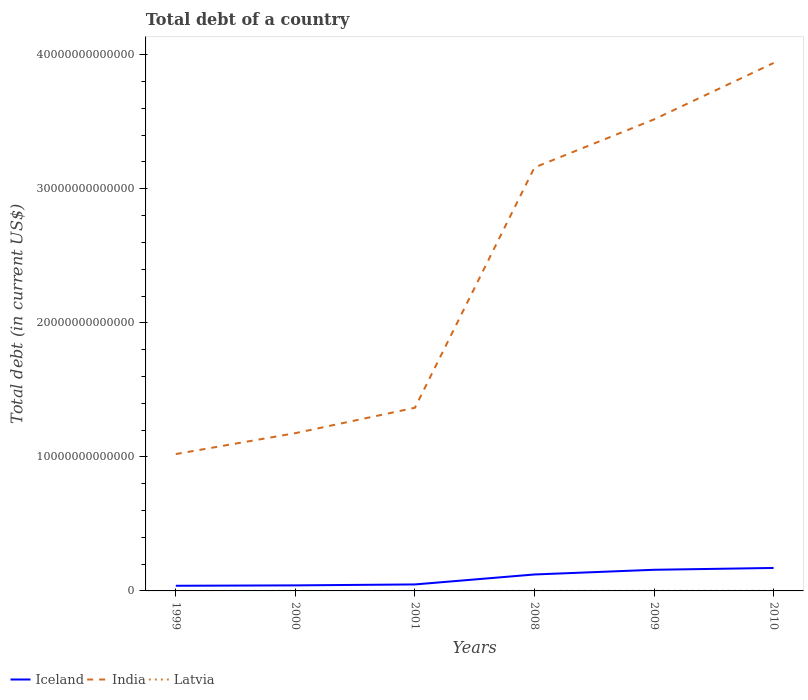How many different coloured lines are there?
Your answer should be compact. 3. Does the line corresponding to Latvia intersect with the line corresponding to India?
Give a very brief answer. No. Is the number of lines equal to the number of legend labels?
Provide a succinct answer. Yes. Across all years, what is the maximum debt in India?
Offer a terse response. 1.02e+13. In which year was the debt in Iceland maximum?
Your answer should be compact. 1999. What is the total debt in India in the graph?
Your response must be concise. -1.79e+13. What is the difference between the highest and the second highest debt in Latvia?
Your answer should be very brief. 5.84e+09. What is the difference between two consecutive major ticks on the Y-axis?
Provide a succinct answer. 1.00e+13. Are the values on the major ticks of Y-axis written in scientific E-notation?
Keep it short and to the point. No. Does the graph contain any zero values?
Offer a terse response. No. Where does the legend appear in the graph?
Ensure brevity in your answer.  Bottom left. How are the legend labels stacked?
Offer a very short reply. Horizontal. What is the title of the graph?
Your answer should be very brief. Total debt of a country. Does "Serbia" appear as one of the legend labels in the graph?
Your answer should be very brief. No. What is the label or title of the X-axis?
Ensure brevity in your answer.  Years. What is the label or title of the Y-axis?
Offer a very short reply. Total debt (in current US$). What is the Total debt (in current US$) of Iceland in 1999?
Your answer should be very brief. 3.84e+11. What is the Total debt (in current US$) of India in 1999?
Give a very brief answer. 1.02e+13. What is the Total debt (in current US$) in Latvia in 1999?
Keep it short and to the point. 5.11e+08. What is the Total debt (in current US$) of Iceland in 2000?
Give a very brief answer. 4.13e+11. What is the Total debt (in current US$) in India in 2000?
Ensure brevity in your answer.  1.18e+13. What is the Total debt (in current US$) of Latvia in 2000?
Provide a short and direct response. 5.71e+08. What is the Total debt (in current US$) of Iceland in 2001?
Give a very brief answer. 4.84e+11. What is the Total debt (in current US$) in India in 2001?
Offer a very short reply. 1.37e+13. What is the Total debt (in current US$) in Latvia in 2001?
Offer a terse response. 7.13e+08. What is the Total debt (in current US$) in Iceland in 2008?
Make the answer very short. 1.23e+12. What is the Total debt (in current US$) of India in 2008?
Your answer should be very brief. 3.16e+13. What is the Total debt (in current US$) of Latvia in 2008?
Your response must be concise. 3.71e+09. What is the Total debt (in current US$) of Iceland in 2009?
Your answer should be very brief. 1.58e+12. What is the Total debt (in current US$) of India in 2009?
Ensure brevity in your answer.  3.52e+13. What is the Total debt (in current US$) in Latvia in 2009?
Provide a succinct answer. 5.52e+09. What is the Total debt (in current US$) in Iceland in 2010?
Ensure brevity in your answer.  1.71e+12. What is the Total debt (in current US$) of India in 2010?
Your answer should be compact. 3.94e+13. What is the Total debt (in current US$) in Latvia in 2010?
Your answer should be very brief. 6.35e+09. Across all years, what is the maximum Total debt (in current US$) in Iceland?
Keep it short and to the point. 1.71e+12. Across all years, what is the maximum Total debt (in current US$) of India?
Provide a succinct answer. 3.94e+13. Across all years, what is the maximum Total debt (in current US$) in Latvia?
Provide a short and direct response. 6.35e+09. Across all years, what is the minimum Total debt (in current US$) of Iceland?
Provide a short and direct response. 3.84e+11. Across all years, what is the minimum Total debt (in current US$) of India?
Your response must be concise. 1.02e+13. Across all years, what is the minimum Total debt (in current US$) of Latvia?
Ensure brevity in your answer.  5.11e+08. What is the total Total debt (in current US$) in Iceland in the graph?
Ensure brevity in your answer.  5.80e+12. What is the total Total debt (in current US$) of India in the graph?
Ensure brevity in your answer.  1.42e+14. What is the total Total debt (in current US$) in Latvia in the graph?
Provide a succinct answer. 1.74e+1. What is the difference between the Total debt (in current US$) of Iceland in 1999 and that in 2000?
Your answer should be very brief. -2.90e+1. What is the difference between the Total debt (in current US$) in India in 1999 and that in 2000?
Make the answer very short. -1.56e+12. What is the difference between the Total debt (in current US$) of Latvia in 1999 and that in 2000?
Make the answer very short. -6.02e+07. What is the difference between the Total debt (in current US$) of Iceland in 1999 and that in 2001?
Keep it short and to the point. -9.93e+1. What is the difference between the Total debt (in current US$) of India in 1999 and that in 2001?
Your response must be concise. -3.45e+12. What is the difference between the Total debt (in current US$) of Latvia in 1999 and that in 2001?
Offer a terse response. -2.02e+08. What is the difference between the Total debt (in current US$) of Iceland in 1999 and that in 2008?
Keep it short and to the point. -8.43e+11. What is the difference between the Total debt (in current US$) in India in 1999 and that in 2008?
Offer a very short reply. -2.14e+13. What is the difference between the Total debt (in current US$) of Latvia in 1999 and that in 2008?
Keep it short and to the point. -3.20e+09. What is the difference between the Total debt (in current US$) of Iceland in 1999 and that in 2009?
Keep it short and to the point. -1.19e+12. What is the difference between the Total debt (in current US$) in India in 1999 and that in 2009?
Your answer should be compact. -2.50e+13. What is the difference between the Total debt (in current US$) of Latvia in 1999 and that in 2009?
Provide a succinct answer. -5.01e+09. What is the difference between the Total debt (in current US$) in Iceland in 1999 and that in 2010?
Ensure brevity in your answer.  -1.33e+12. What is the difference between the Total debt (in current US$) in India in 1999 and that in 2010?
Your answer should be very brief. -2.92e+13. What is the difference between the Total debt (in current US$) in Latvia in 1999 and that in 2010?
Your response must be concise. -5.84e+09. What is the difference between the Total debt (in current US$) of Iceland in 2000 and that in 2001?
Your answer should be compact. -7.03e+1. What is the difference between the Total debt (in current US$) of India in 2000 and that in 2001?
Make the answer very short. -1.89e+12. What is the difference between the Total debt (in current US$) of Latvia in 2000 and that in 2001?
Make the answer very short. -1.42e+08. What is the difference between the Total debt (in current US$) of Iceland in 2000 and that in 2008?
Make the answer very short. -8.14e+11. What is the difference between the Total debt (in current US$) of India in 2000 and that in 2008?
Offer a very short reply. -1.98e+13. What is the difference between the Total debt (in current US$) of Latvia in 2000 and that in 2008?
Provide a short and direct response. -3.14e+09. What is the difference between the Total debt (in current US$) in Iceland in 2000 and that in 2009?
Provide a succinct answer. -1.16e+12. What is the difference between the Total debt (in current US$) of India in 2000 and that in 2009?
Provide a short and direct response. -2.34e+13. What is the difference between the Total debt (in current US$) of Latvia in 2000 and that in 2009?
Provide a short and direct response. -4.95e+09. What is the difference between the Total debt (in current US$) in Iceland in 2000 and that in 2010?
Provide a succinct answer. -1.30e+12. What is the difference between the Total debt (in current US$) of India in 2000 and that in 2010?
Offer a very short reply. -2.76e+13. What is the difference between the Total debt (in current US$) of Latvia in 2000 and that in 2010?
Offer a terse response. -5.78e+09. What is the difference between the Total debt (in current US$) of Iceland in 2001 and that in 2008?
Keep it short and to the point. -7.44e+11. What is the difference between the Total debt (in current US$) in India in 2001 and that in 2008?
Offer a very short reply. -1.79e+13. What is the difference between the Total debt (in current US$) in Latvia in 2001 and that in 2008?
Make the answer very short. -2.99e+09. What is the difference between the Total debt (in current US$) of Iceland in 2001 and that in 2009?
Provide a short and direct response. -1.09e+12. What is the difference between the Total debt (in current US$) in India in 2001 and that in 2009?
Your response must be concise. -2.15e+13. What is the difference between the Total debt (in current US$) in Latvia in 2001 and that in 2009?
Your answer should be very brief. -4.80e+09. What is the difference between the Total debt (in current US$) in Iceland in 2001 and that in 2010?
Offer a terse response. -1.23e+12. What is the difference between the Total debt (in current US$) in India in 2001 and that in 2010?
Ensure brevity in your answer.  -2.57e+13. What is the difference between the Total debt (in current US$) of Latvia in 2001 and that in 2010?
Your answer should be very brief. -5.64e+09. What is the difference between the Total debt (in current US$) in Iceland in 2008 and that in 2009?
Your answer should be very brief. -3.50e+11. What is the difference between the Total debt (in current US$) of India in 2008 and that in 2009?
Offer a terse response. -3.59e+12. What is the difference between the Total debt (in current US$) of Latvia in 2008 and that in 2009?
Your answer should be very brief. -1.81e+09. What is the difference between the Total debt (in current US$) in Iceland in 2008 and that in 2010?
Provide a succinct answer. -4.86e+11. What is the difference between the Total debt (in current US$) in India in 2008 and that in 2010?
Provide a short and direct response. -7.80e+12. What is the difference between the Total debt (in current US$) of Latvia in 2008 and that in 2010?
Your answer should be very brief. -2.65e+09. What is the difference between the Total debt (in current US$) in Iceland in 2009 and that in 2010?
Your answer should be very brief. -1.36e+11. What is the difference between the Total debt (in current US$) of India in 2009 and that in 2010?
Offer a very short reply. -4.21e+12. What is the difference between the Total debt (in current US$) in Latvia in 2009 and that in 2010?
Your response must be concise. -8.37e+08. What is the difference between the Total debt (in current US$) in Iceland in 1999 and the Total debt (in current US$) in India in 2000?
Provide a succinct answer. -1.14e+13. What is the difference between the Total debt (in current US$) of Iceland in 1999 and the Total debt (in current US$) of Latvia in 2000?
Provide a succinct answer. 3.84e+11. What is the difference between the Total debt (in current US$) in India in 1999 and the Total debt (in current US$) in Latvia in 2000?
Offer a very short reply. 1.02e+13. What is the difference between the Total debt (in current US$) of Iceland in 1999 and the Total debt (in current US$) of India in 2001?
Offer a terse response. -1.33e+13. What is the difference between the Total debt (in current US$) in Iceland in 1999 and the Total debt (in current US$) in Latvia in 2001?
Make the answer very short. 3.84e+11. What is the difference between the Total debt (in current US$) of India in 1999 and the Total debt (in current US$) of Latvia in 2001?
Offer a terse response. 1.02e+13. What is the difference between the Total debt (in current US$) of Iceland in 1999 and the Total debt (in current US$) of India in 2008?
Give a very brief answer. -3.12e+13. What is the difference between the Total debt (in current US$) in Iceland in 1999 and the Total debt (in current US$) in Latvia in 2008?
Keep it short and to the point. 3.81e+11. What is the difference between the Total debt (in current US$) of India in 1999 and the Total debt (in current US$) of Latvia in 2008?
Offer a very short reply. 1.02e+13. What is the difference between the Total debt (in current US$) in Iceland in 1999 and the Total debt (in current US$) in India in 2009?
Your answer should be compact. -3.48e+13. What is the difference between the Total debt (in current US$) of Iceland in 1999 and the Total debt (in current US$) of Latvia in 2009?
Offer a very short reply. 3.79e+11. What is the difference between the Total debt (in current US$) of India in 1999 and the Total debt (in current US$) of Latvia in 2009?
Ensure brevity in your answer.  1.02e+13. What is the difference between the Total debt (in current US$) of Iceland in 1999 and the Total debt (in current US$) of India in 2010?
Make the answer very short. -3.90e+13. What is the difference between the Total debt (in current US$) of Iceland in 1999 and the Total debt (in current US$) of Latvia in 2010?
Give a very brief answer. 3.78e+11. What is the difference between the Total debt (in current US$) in India in 1999 and the Total debt (in current US$) in Latvia in 2010?
Give a very brief answer. 1.02e+13. What is the difference between the Total debt (in current US$) of Iceland in 2000 and the Total debt (in current US$) of India in 2001?
Make the answer very short. -1.33e+13. What is the difference between the Total debt (in current US$) of Iceland in 2000 and the Total debt (in current US$) of Latvia in 2001?
Provide a succinct answer. 4.13e+11. What is the difference between the Total debt (in current US$) in India in 2000 and the Total debt (in current US$) in Latvia in 2001?
Offer a terse response. 1.18e+13. What is the difference between the Total debt (in current US$) of Iceland in 2000 and the Total debt (in current US$) of India in 2008?
Provide a short and direct response. -3.12e+13. What is the difference between the Total debt (in current US$) in Iceland in 2000 and the Total debt (in current US$) in Latvia in 2008?
Make the answer very short. 4.10e+11. What is the difference between the Total debt (in current US$) of India in 2000 and the Total debt (in current US$) of Latvia in 2008?
Ensure brevity in your answer.  1.18e+13. What is the difference between the Total debt (in current US$) of Iceland in 2000 and the Total debt (in current US$) of India in 2009?
Offer a terse response. -3.48e+13. What is the difference between the Total debt (in current US$) in Iceland in 2000 and the Total debt (in current US$) in Latvia in 2009?
Give a very brief answer. 4.08e+11. What is the difference between the Total debt (in current US$) of India in 2000 and the Total debt (in current US$) of Latvia in 2009?
Give a very brief answer. 1.18e+13. What is the difference between the Total debt (in current US$) of Iceland in 2000 and the Total debt (in current US$) of India in 2010?
Your answer should be compact. -3.90e+13. What is the difference between the Total debt (in current US$) in Iceland in 2000 and the Total debt (in current US$) in Latvia in 2010?
Make the answer very short. 4.07e+11. What is the difference between the Total debt (in current US$) of India in 2000 and the Total debt (in current US$) of Latvia in 2010?
Your response must be concise. 1.18e+13. What is the difference between the Total debt (in current US$) of Iceland in 2001 and the Total debt (in current US$) of India in 2008?
Provide a succinct answer. -3.11e+13. What is the difference between the Total debt (in current US$) in Iceland in 2001 and the Total debt (in current US$) in Latvia in 2008?
Provide a succinct answer. 4.80e+11. What is the difference between the Total debt (in current US$) of India in 2001 and the Total debt (in current US$) of Latvia in 2008?
Offer a terse response. 1.37e+13. What is the difference between the Total debt (in current US$) of Iceland in 2001 and the Total debt (in current US$) of India in 2009?
Your answer should be very brief. -3.47e+13. What is the difference between the Total debt (in current US$) in Iceland in 2001 and the Total debt (in current US$) in Latvia in 2009?
Keep it short and to the point. 4.78e+11. What is the difference between the Total debt (in current US$) in India in 2001 and the Total debt (in current US$) in Latvia in 2009?
Give a very brief answer. 1.37e+13. What is the difference between the Total debt (in current US$) in Iceland in 2001 and the Total debt (in current US$) in India in 2010?
Keep it short and to the point. -3.89e+13. What is the difference between the Total debt (in current US$) of Iceland in 2001 and the Total debt (in current US$) of Latvia in 2010?
Provide a succinct answer. 4.77e+11. What is the difference between the Total debt (in current US$) of India in 2001 and the Total debt (in current US$) of Latvia in 2010?
Offer a terse response. 1.37e+13. What is the difference between the Total debt (in current US$) in Iceland in 2008 and the Total debt (in current US$) in India in 2009?
Provide a succinct answer. -3.40e+13. What is the difference between the Total debt (in current US$) in Iceland in 2008 and the Total debt (in current US$) in Latvia in 2009?
Provide a succinct answer. 1.22e+12. What is the difference between the Total debt (in current US$) in India in 2008 and the Total debt (in current US$) in Latvia in 2009?
Your answer should be compact. 3.16e+13. What is the difference between the Total debt (in current US$) of Iceland in 2008 and the Total debt (in current US$) of India in 2010?
Provide a short and direct response. -3.82e+13. What is the difference between the Total debt (in current US$) in Iceland in 2008 and the Total debt (in current US$) in Latvia in 2010?
Provide a succinct answer. 1.22e+12. What is the difference between the Total debt (in current US$) in India in 2008 and the Total debt (in current US$) in Latvia in 2010?
Provide a succinct answer. 3.16e+13. What is the difference between the Total debt (in current US$) in Iceland in 2009 and the Total debt (in current US$) in India in 2010?
Offer a very short reply. -3.78e+13. What is the difference between the Total debt (in current US$) of Iceland in 2009 and the Total debt (in current US$) of Latvia in 2010?
Offer a very short reply. 1.57e+12. What is the difference between the Total debt (in current US$) of India in 2009 and the Total debt (in current US$) of Latvia in 2010?
Keep it short and to the point. 3.52e+13. What is the average Total debt (in current US$) of Iceland per year?
Your answer should be compact. 9.67e+11. What is the average Total debt (in current US$) of India per year?
Provide a succinct answer. 2.36e+13. What is the average Total debt (in current US$) in Latvia per year?
Your answer should be very brief. 2.89e+09. In the year 1999, what is the difference between the Total debt (in current US$) in Iceland and Total debt (in current US$) in India?
Your response must be concise. -9.83e+12. In the year 1999, what is the difference between the Total debt (in current US$) of Iceland and Total debt (in current US$) of Latvia?
Your response must be concise. 3.84e+11. In the year 1999, what is the difference between the Total debt (in current US$) of India and Total debt (in current US$) of Latvia?
Ensure brevity in your answer.  1.02e+13. In the year 2000, what is the difference between the Total debt (in current US$) of Iceland and Total debt (in current US$) of India?
Give a very brief answer. -1.14e+13. In the year 2000, what is the difference between the Total debt (in current US$) in Iceland and Total debt (in current US$) in Latvia?
Your response must be concise. 4.13e+11. In the year 2000, what is the difference between the Total debt (in current US$) of India and Total debt (in current US$) of Latvia?
Provide a short and direct response. 1.18e+13. In the year 2001, what is the difference between the Total debt (in current US$) in Iceland and Total debt (in current US$) in India?
Provide a short and direct response. -1.32e+13. In the year 2001, what is the difference between the Total debt (in current US$) in Iceland and Total debt (in current US$) in Latvia?
Make the answer very short. 4.83e+11. In the year 2001, what is the difference between the Total debt (in current US$) of India and Total debt (in current US$) of Latvia?
Your response must be concise. 1.37e+13. In the year 2008, what is the difference between the Total debt (in current US$) of Iceland and Total debt (in current US$) of India?
Provide a short and direct response. -3.04e+13. In the year 2008, what is the difference between the Total debt (in current US$) in Iceland and Total debt (in current US$) in Latvia?
Provide a short and direct response. 1.22e+12. In the year 2008, what is the difference between the Total debt (in current US$) of India and Total debt (in current US$) of Latvia?
Give a very brief answer. 3.16e+13. In the year 2009, what is the difference between the Total debt (in current US$) of Iceland and Total debt (in current US$) of India?
Provide a short and direct response. -3.36e+13. In the year 2009, what is the difference between the Total debt (in current US$) in Iceland and Total debt (in current US$) in Latvia?
Your answer should be very brief. 1.57e+12. In the year 2009, what is the difference between the Total debt (in current US$) of India and Total debt (in current US$) of Latvia?
Your response must be concise. 3.52e+13. In the year 2010, what is the difference between the Total debt (in current US$) in Iceland and Total debt (in current US$) in India?
Provide a succinct answer. -3.77e+13. In the year 2010, what is the difference between the Total debt (in current US$) in Iceland and Total debt (in current US$) in Latvia?
Provide a short and direct response. 1.71e+12. In the year 2010, what is the difference between the Total debt (in current US$) in India and Total debt (in current US$) in Latvia?
Ensure brevity in your answer.  3.94e+13. What is the ratio of the Total debt (in current US$) in Iceland in 1999 to that in 2000?
Offer a very short reply. 0.93. What is the ratio of the Total debt (in current US$) in India in 1999 to that in 2000?
Ensure brevity in your answer.  0.87. What is the ratio of the Total debt (in current US$) of Latvia in 1999 to that in 2000?
Provide a short and direct response. 0.89. What is the ratio of the Total debt (in current US$) in Iceland in 1999 to that in 2001?
Give a very brief answer. 0.79. What is the ratio of the Total debt (in current US$) in India in 1999 to that in 2001?
Give a very brief answer. 0.75. What is the ratio of the Total debt (in current US$) of Latvia in 1999 to that in 2001?
Ensure brevity in your answer.  0.72. What is the ratio of the Total debt (in current US$) in Iceland in 1999 to that in 2008?
Offer a very short reply. 0.31. What is the ratio of the Total debt (in current US$) in India in 1999 to that in 2008?
Your answer should be very brief. 0.32. What is the ratio of the Total debt (in current US$) of Latvia in 1999 to that in 2008?
Provide a short and direct response. 0.14. What is the ratio of the Total debt (in current US$) of Iceland in 1999 to that in 2009?
Offer a very short reply. 0.24. What is the ratio of the Total debt (in current US$) in India in 1999 to that in 2009?
Make the answer very short. 0.29. What is the ratio of the Total debt (in current US$) of Latvia in 1999 to that in 2009?
Make the answer very short. 0.09. What is the ratio of the Total debt (in current US$) of Iceland in 1999 to that in 2010?
Your response must be concise. 0.22. What is the ratio of the Total debt (in current US$) of India in 1999 to that in 2010?
Provide a succinct answer. 0.26. What is the ratio of the Total debt (in current US$) in Latvia in 1999 to that in 2010?
Make the answer very short. 0.08. What is the ratio of the Total debt (in current US$) of Iceland in 2000 to that in 2001?
Make the answer very short. 0.85. What is the ratio of the Total debt (in current US$) of India in 2000 to that in 2001?
Ensure brevity in your answer.  0.86. What is the ratio of the Total debt (in current US$) in Latvia in 2000 to that in 2001?
Make the answer very short. 0.8. What is the ratio of the Total debt (in current US$) of Iceland in 2000 to that in 2008?
Make the answer very short. 0.34. What is the ratio of the Total debt (in current US$) of India in 2000 to that in 2008?
Provide a succinct answer. 0.37. What is the ratio of the Total debt (in current US$) in Latvia in 2000 to that in 2008?
Make the answer very short. 0.15. What is the ratio of the Total debt (in current US$) in Iceland in 2000 to that in 2009?
Offer a terse response. 0.26. What is the ratio of the Total debt (in current US$) of India in 2000 to that in 2009?
Give a very brief answer. 0.33. What is the ratio of the Total debt (in current US$) of Latvia in 2000 to that in 2009?
Provide a short and direct response. 0.1. What is the ratio of the Total debt (in current US$) of Iceland in 2000 to that in 2010?
Offer a very short reply. 0.24. What is the ratio of the Total debt (in current US$) of India in 2000 to that in 2010?
Give a very brief answer. 0.3. What is the ratio of the Total debt (in current US$) of Latvia in 2000 to that in 2010?
Keep it short and to the point. 0.09. What is the ratio of the Total debt (in current US$) of Iceland in 2001 to that in 2008?
Provide a short and direct response. 0.39. What is the ratio of the Total debt (in current US$) in India in 2001 to that in 2008?
Keep it short and to the point. 0.43. What is the ratio of the Total debt (in current US$) in Latvia in 2001 to that in 2008?
Your answer should be compact. 0.19. What is the ratio of the Total debt (in current US$) of Iceland in 2001 to that in 2009?
Offer a very short reply. 0.31. What is the ratio of the Total debt (in current US$) of India in 2001 to that in 2009?
Offer a terse response. 0.39. What is the ratio of the Total debt (in current US$) in Latvia in 2001 to that in 2009?
Provide a short and direct response. 0.13. What is the ratio of the Total debt (in current US$) in Iceland in 2001 to that in 2010?
Your answer should be very brief. 0.28. What is the ratio of the Total debt (in current US$) of India in 2001 to that in 2010?
Provide a succinct answer. 0.35. What is the ratio of the Total debt (in current US$) of Latvia in 2001 to that in 2010?
Your response must be concise. 0.11. What is the ratio of the Total debt (in current US$) of Iceland in 2008 to that in 2009?
Offer a terse response. 0.78. What is the ratio of the Total debt (in current US$) in India in 2008 to that in 2009?
Give a very brief answer. 0.9. What is the ratio of the Total debt (in current US$) in Latvia in 2008 to that in 2009?
Give a very brief answer. 0.67. What is the ratio of the Total debt (in current US$) of Iceland in 2008 to that in 2010?
Provide a succinct answer. 0.72. What is the ratio of the Total debt (in current US$) of India in 2008 to that in 2010?
Keep it short and to the point. 0.8. What is the ratio of the Total debt (in current US$) of Latvia in 2008 to that in 2010?
Your response must be concise. 0.58. What is the ratio of the Total debt (in current US$) in Iceland in 2009 to that in 2010?
Your answer should be compact. 0.92. What is the ratio of the Total debt (in current US$) in India in 2009 to that in 2010?
Offer a terse response. 0.89. What is the ratio of the Total debt (in current US$) of Latvia in 2009 to that in 2010?
Offer a very short reply. 0.87. What is the difference between the highest and the second highest Total debt (in current US$) in Iceland?
Ensure brevity in your answer.  1.36e+11. What is the difference between the highest and the second highest Total debt (in current US$) of India?
Offer a very short reply. 4.21e+12. What is the difference between the highest and the second highest Total debt (in current US$) in Latvia?
Your response must be concise. 8.37e+08. What is the difference between the highest and the lowest Total debt (in current US$) in Iceland?
Provide a succinct answer. 1.33e+12. What is the difference between the highest and the lowest Total debt (in current US$) in India?
Offer a very short reply. 2.92e+13. What is the difference between the highest and the lowest Total debt (in current US$) of Latvia?
Provide a short and direct response. 5.84e+09. 